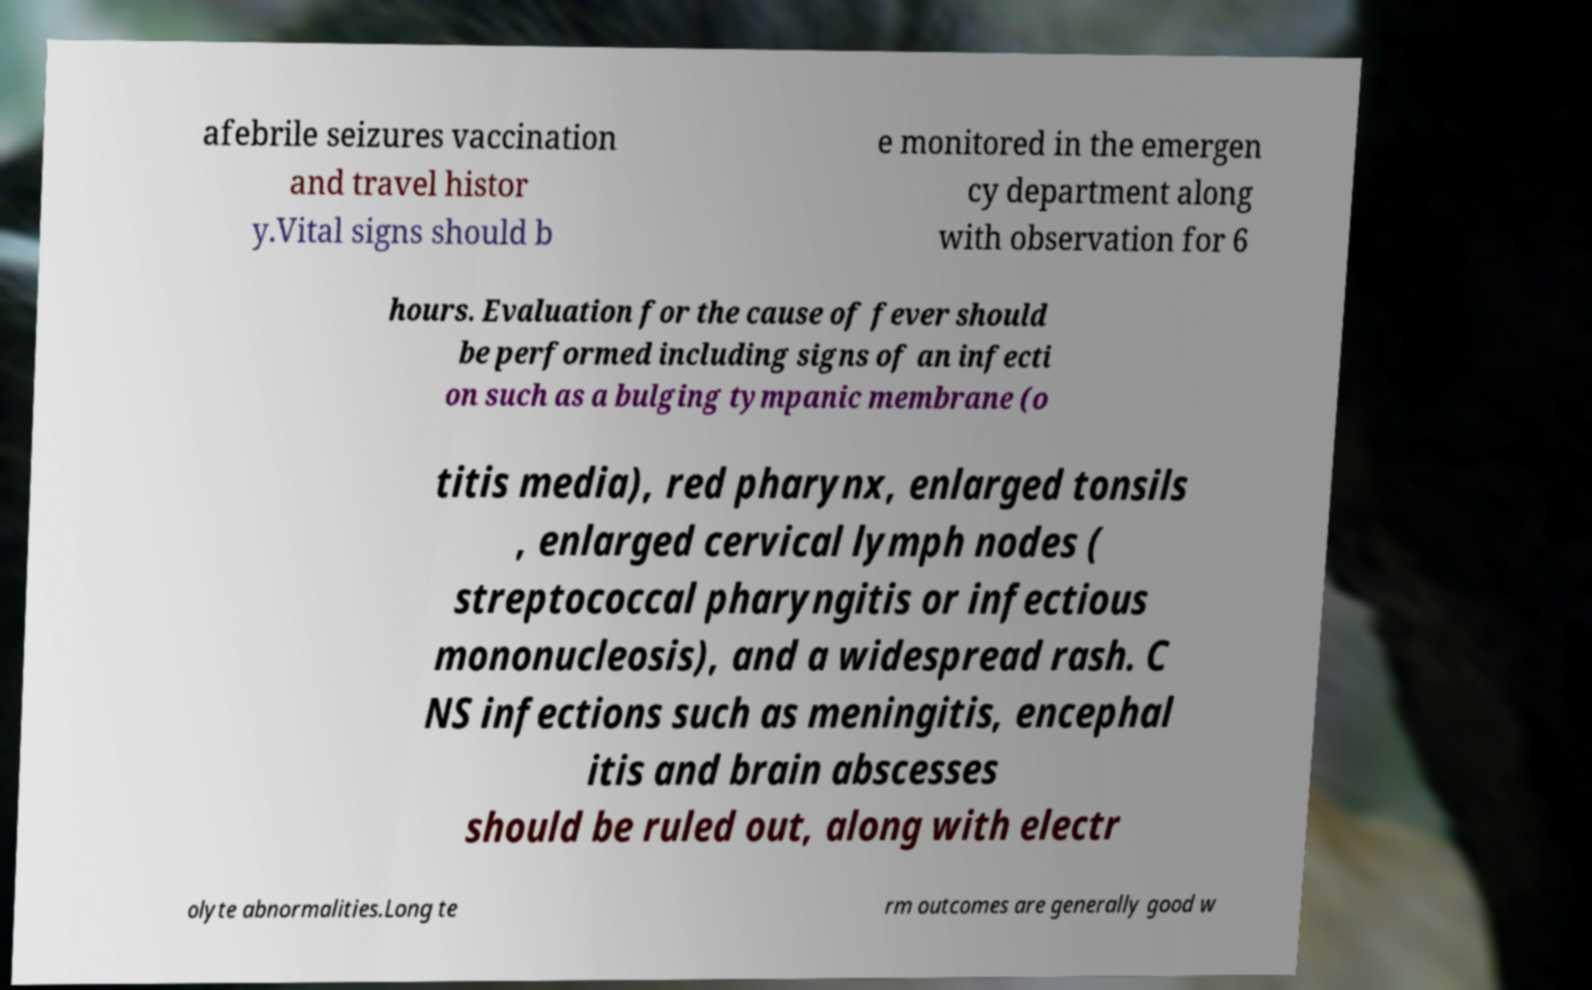I need the written content from this picture converted into text. Can you do that? afebrile seizures vaccination and travel histor y.Vital signs should b e monitored in the emergen cy department along with observation for 6 hours. Evaluation for the cause of fever should be performed including signs of an infecti on such as a bulging tympanic membrane (o titis media), red pharynx, enlarged tonsils , enlarged cervical lymph nodes ( streptococcal pharyngitis or infectious mononucleosis), and a widespread rash. C NS infections such as meningitis, encephal itis and brain abscesses should be ruled out, along with electr olyte abnormalities.Long te rm outcomes are generally good w 